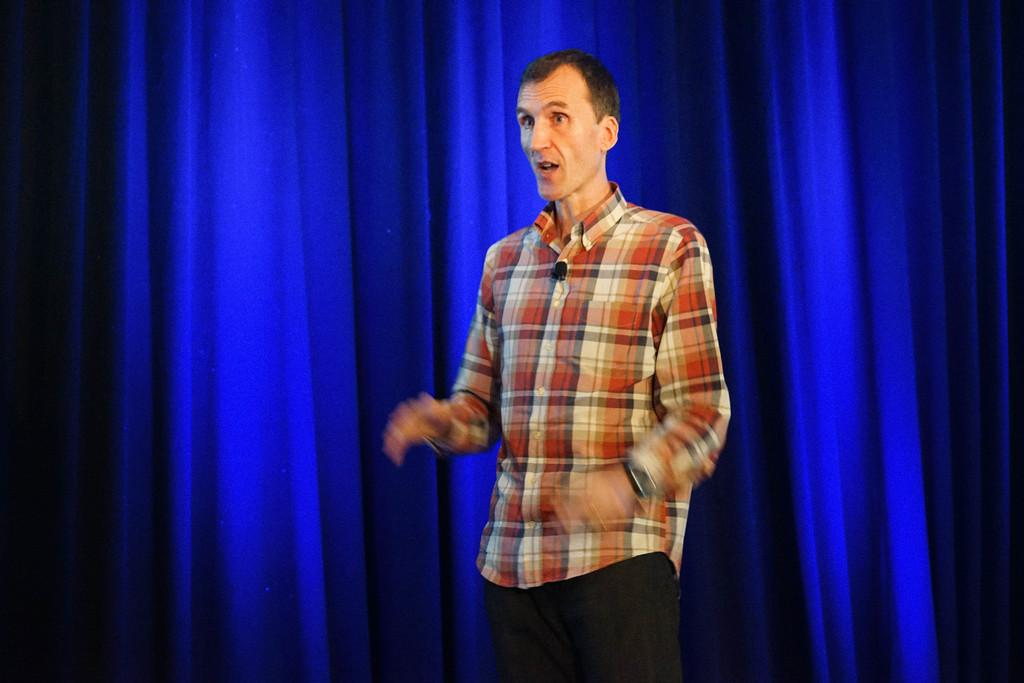What is the main subject in the front of the image? There is a man standing in the front of the image. What can be seen in the background of the image? There are blue color curtains in the background of the image. How many pets can be seen in the image? There are no pets visible in the image. What type of bikes are present in the image? There are no bikes present in the image. 